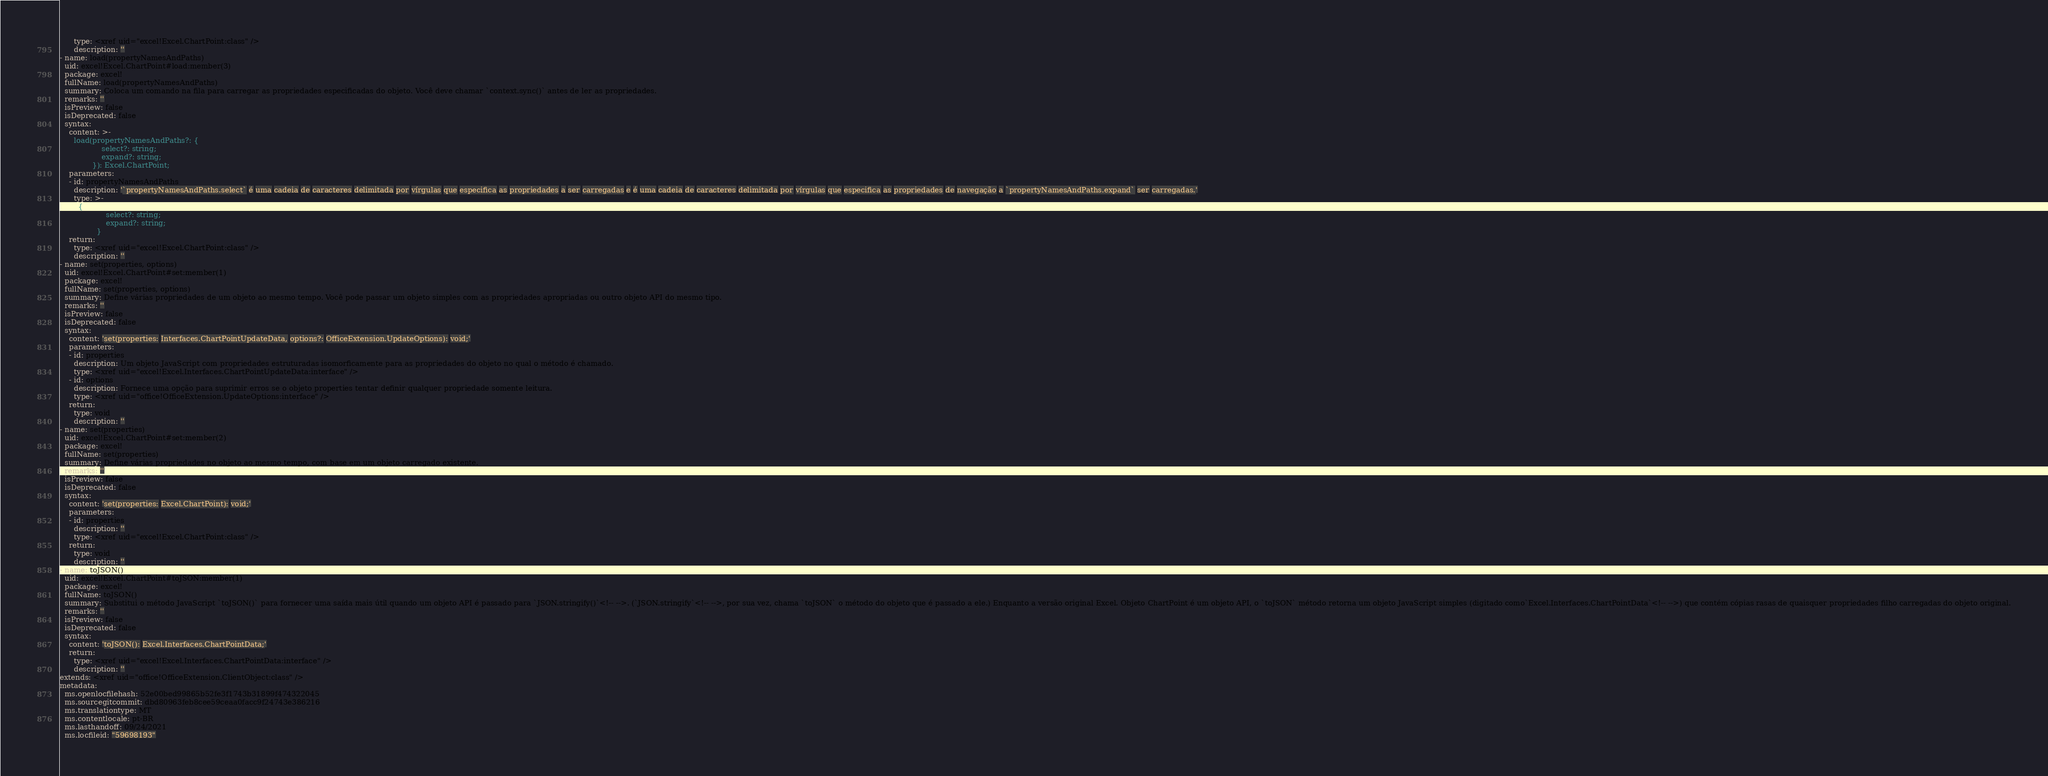Convert code to text. <code><loc_0><loc_0><loc_500><loc_500><_YAML_>      type: <xref uid="excel!Excel.ChartPoint:class" />
      description: ''
- name: load(propertyNamesAndPaths)
  uid: excel!Excel.ChartPoint#load:member(3)
  package: excel!
  fullName: load(propertyNamesAndPaths)
  summary: Coloca um comando na fila para carregar as propriedades especificadas do objeto. Você deve chamar `context.sync()` antes de ler as propriedades.
  remarks: ''
  isPreview: false
  isDeprecated: false
  syntax:
    content: >-
      load(propertyNamesAndPaths?: {
                  select?: string;
                  expand?: string;
              }): Excel.ChartPoint;
    parameters:
    - id: propertyNamesAndPaths
      description: '`propertyNamesAndPaths.select` é uma cadeia de caracteres delimitada por vírgulas que especifica as propriedades a ser carregadas e é uma cadeia de caracteres delimitada por vírgulas que especifica as propriedades de navegação a `propertyNamesAndPaths.expand` ser carregadas.'
      type: >-
        {
                    select?: string;
                    expand?: string;
                }
    return:
      type: <xref uid="excel!Excel.ChartPoint:class" />
      description: ''
- name: set(properties, options)
  uid: excel!Excel.ChartPoint#set:member(1)
  package: excel!
  fullName: set(properties, options)
  summary: Define várias propriedades de um objeto ao mesmo tempo. Você pode passar um objeto simples com as propriedades apropriadas ou outro objeto API do mesmo tipo.
  remarks: ''
  isPreview: false
  isDeprecated: false
  syntax:
    content: 'set(properties: Interfaces.ChartPointUpdateData, options?: OfficeExtension.UpdateOptions): void;'
    parameters:
    - id: properties
      description: Um objeto JavaScript com propriedades estruturadas isomorficamente para as propriedades do objeto no qual o método é chamado.
      type: <xref uid="excel!Excel.Interfaces.ChartPointUpdateData:interface" />
    - id: options
      description: Fornece uma opção para suprimir erros se o objeto properties tentar definir qualquer propriedade somente leitura.
      type: <xref uid="office!OfficeExtension.UpdateOptions:interface" />
    return:
      type: void
      description: ''
- name: set(properties)
  uid: excel!Excel.ChartPoint#set:member(2)
  package: excel!
  fullName: set(properties)
  summary: Define várias propriedades no objeto ao mesmo tempo, com base em um objeto carregado existente.
  remarks: ''
  isPreview: false
  isDeprecated: false
  syntax:
    content: 'set(properties: Excel.ChartPoint): void;'
    parameters:
    - id: properties
      description: ''
      type: <xref uid="excel!Excel.ChartPoint:class" />
    return:
      type: void
      description: ''
- name: toJSON()
  uid: excel!Excel.ChartPoint#toJSON:member(1)
  package: excel!
  fullName: toJSON()
  summary: Substitui o método JavaScript `toJSON()` para fornecer uma saída mais útil quando um objeto API é passado para `JSON.stringify()`<!-- -->. (`JSON.stringify`<!-- -->, por sua vez, chama `toJSON` o método do objeto que é passado a ele.) Enquanto a versão original Excel. Objeto ChartPoint é um objeto API, o `toJSON` método retorna um objeto JavaScript simples (digitado como`Excel.Interfaces.ChartPointData`<!-- -->) que contém cópias rasas de quaisquer propriedades filho carregadas do objeto original.
  remarks: ''
  isPreview: false
  isDeprecated: false
  syntax:
    content: 'toJSON(): Excel.Interfaces.ChartPointData;'
    return:
      type: <xref uid="excel!Excel.Interfaces.ChartPointData:interface" />
      description: ''
extends: <xref uid="office!OfficeExtension.ClientObject:class" />
metadata:
  ms.openlocfilehash: 52e00bed99865b52fe3f1743b31899f474322045
  ms.sourcegitcommit: dbd80963feb8cee59ceaa0facc9f24743e386216
  ms.translationtype: MT
  ms.contentlocale: pt-BR
  ms.lasthandoff: 09/24/2021
  ms.locfileid: "59698193"
</code> 